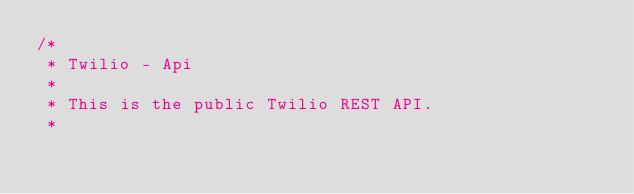<code> <loc_0><loc_0><loc_500><loc_500><_Rust_>/*
 * Twilio - Api
 *
 * This is the public Twilio REST API.
 *</code> 